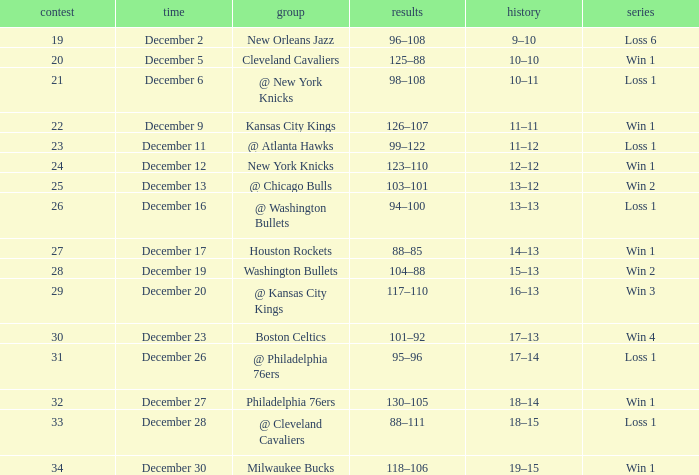What is the Streak on December 30? Win 1. 